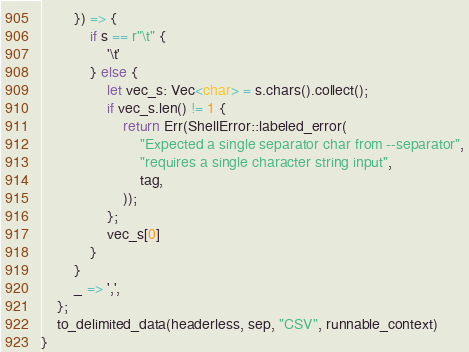Convert code to text. <code><loc_0><loc_0><loc_500><loc_500><_Rust_>        }) => {
            if s == r"\t" {
                '\t'
            } else {
                let vec_s: Vec<char> = s.chars().collect();
                if vec_s.len() != 1 {
                    return Err(ShellError::labeled_error(
                        "Expected a single separator char from --separator",
                        "requires a single character string input",
                        tag,
                    ));
                };
                vec_s[0]
            }
        }
        _ => ',',
    };
    to_delimited_data(headerless, sep, "CSV", runnable_context)
}
</code> 